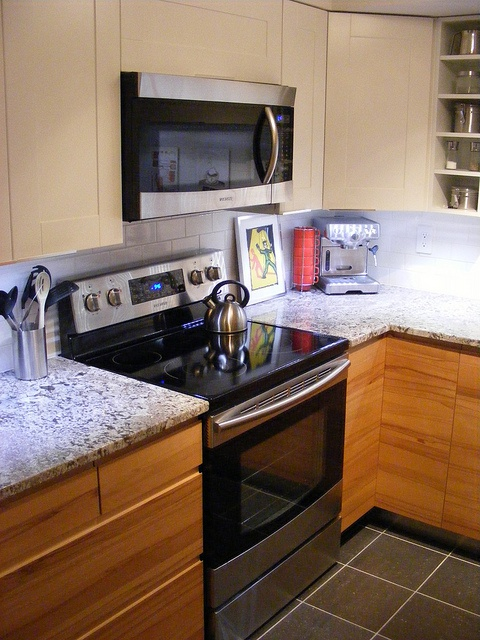Describe the objects in this image and their specific colors. I can see oven in gray, black, maroon, and darkgray tones, microwave in gray, black, darkgray, and tan tones, spoon in gray, darkgray, and lightgray tones, spoon in gray, black, navy, and darkgray tones, and cup in gray, salmon, brown, and violet tones in this image. 